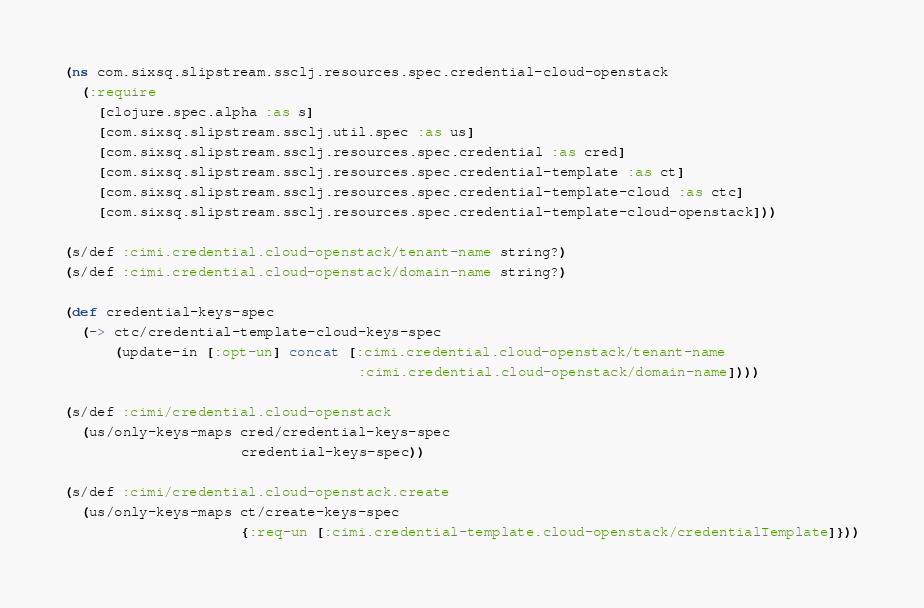<code> <loc_0><loc_0><loc_500><loc_500><_Clojure_>(ns com.sixsq.slipstream.ssclj.resources.spec.credential-cloud-openstack
  (:require
    [clojure.spec.alpha :as s]
    [com.sixsq.slipstream.ssclj.util.spec :as us]
    [com.sixsq.slipstream.ssclj.resources.spec.credential :as cred]
    [com.sixsq.slipstream.ssclj.resources.spec.credential-template :as ct]
    [com.sixsq.slipstream.ssclj.resources.spec.credential-template-cloud :as ctc]
    [com.sixsq.slipstream.ssclj.resources.spec.credential-template-cloud-openstack]))

(s/def :cimi.credential.cloud-openstack/tenant-name string?)
(s/def :cimi.credential.cloud-openstack/domain-name string?)

(def credential-keys-spec
  (-> ctc/credential-template-cloud-keys-spec
      (update-in [:opt-un] concat [:cimi.credential.cloud-openstack/tenant-name
                                   :cimi.credential.cloud-openstack/domain-name])))

(s/def :cimi/credential.cloud-openstack
  (us/only-keys-maps cred/credential-keys-spec
                     credential-keys-spec))

(s/def :cimi/credential.cloud-openstack.create
  (us/only-keys-maps ct/create-keys-spec
                     {:req-un [:cimi.credential-template.cloud-openstack/credentialTemplate]}))
</code> 